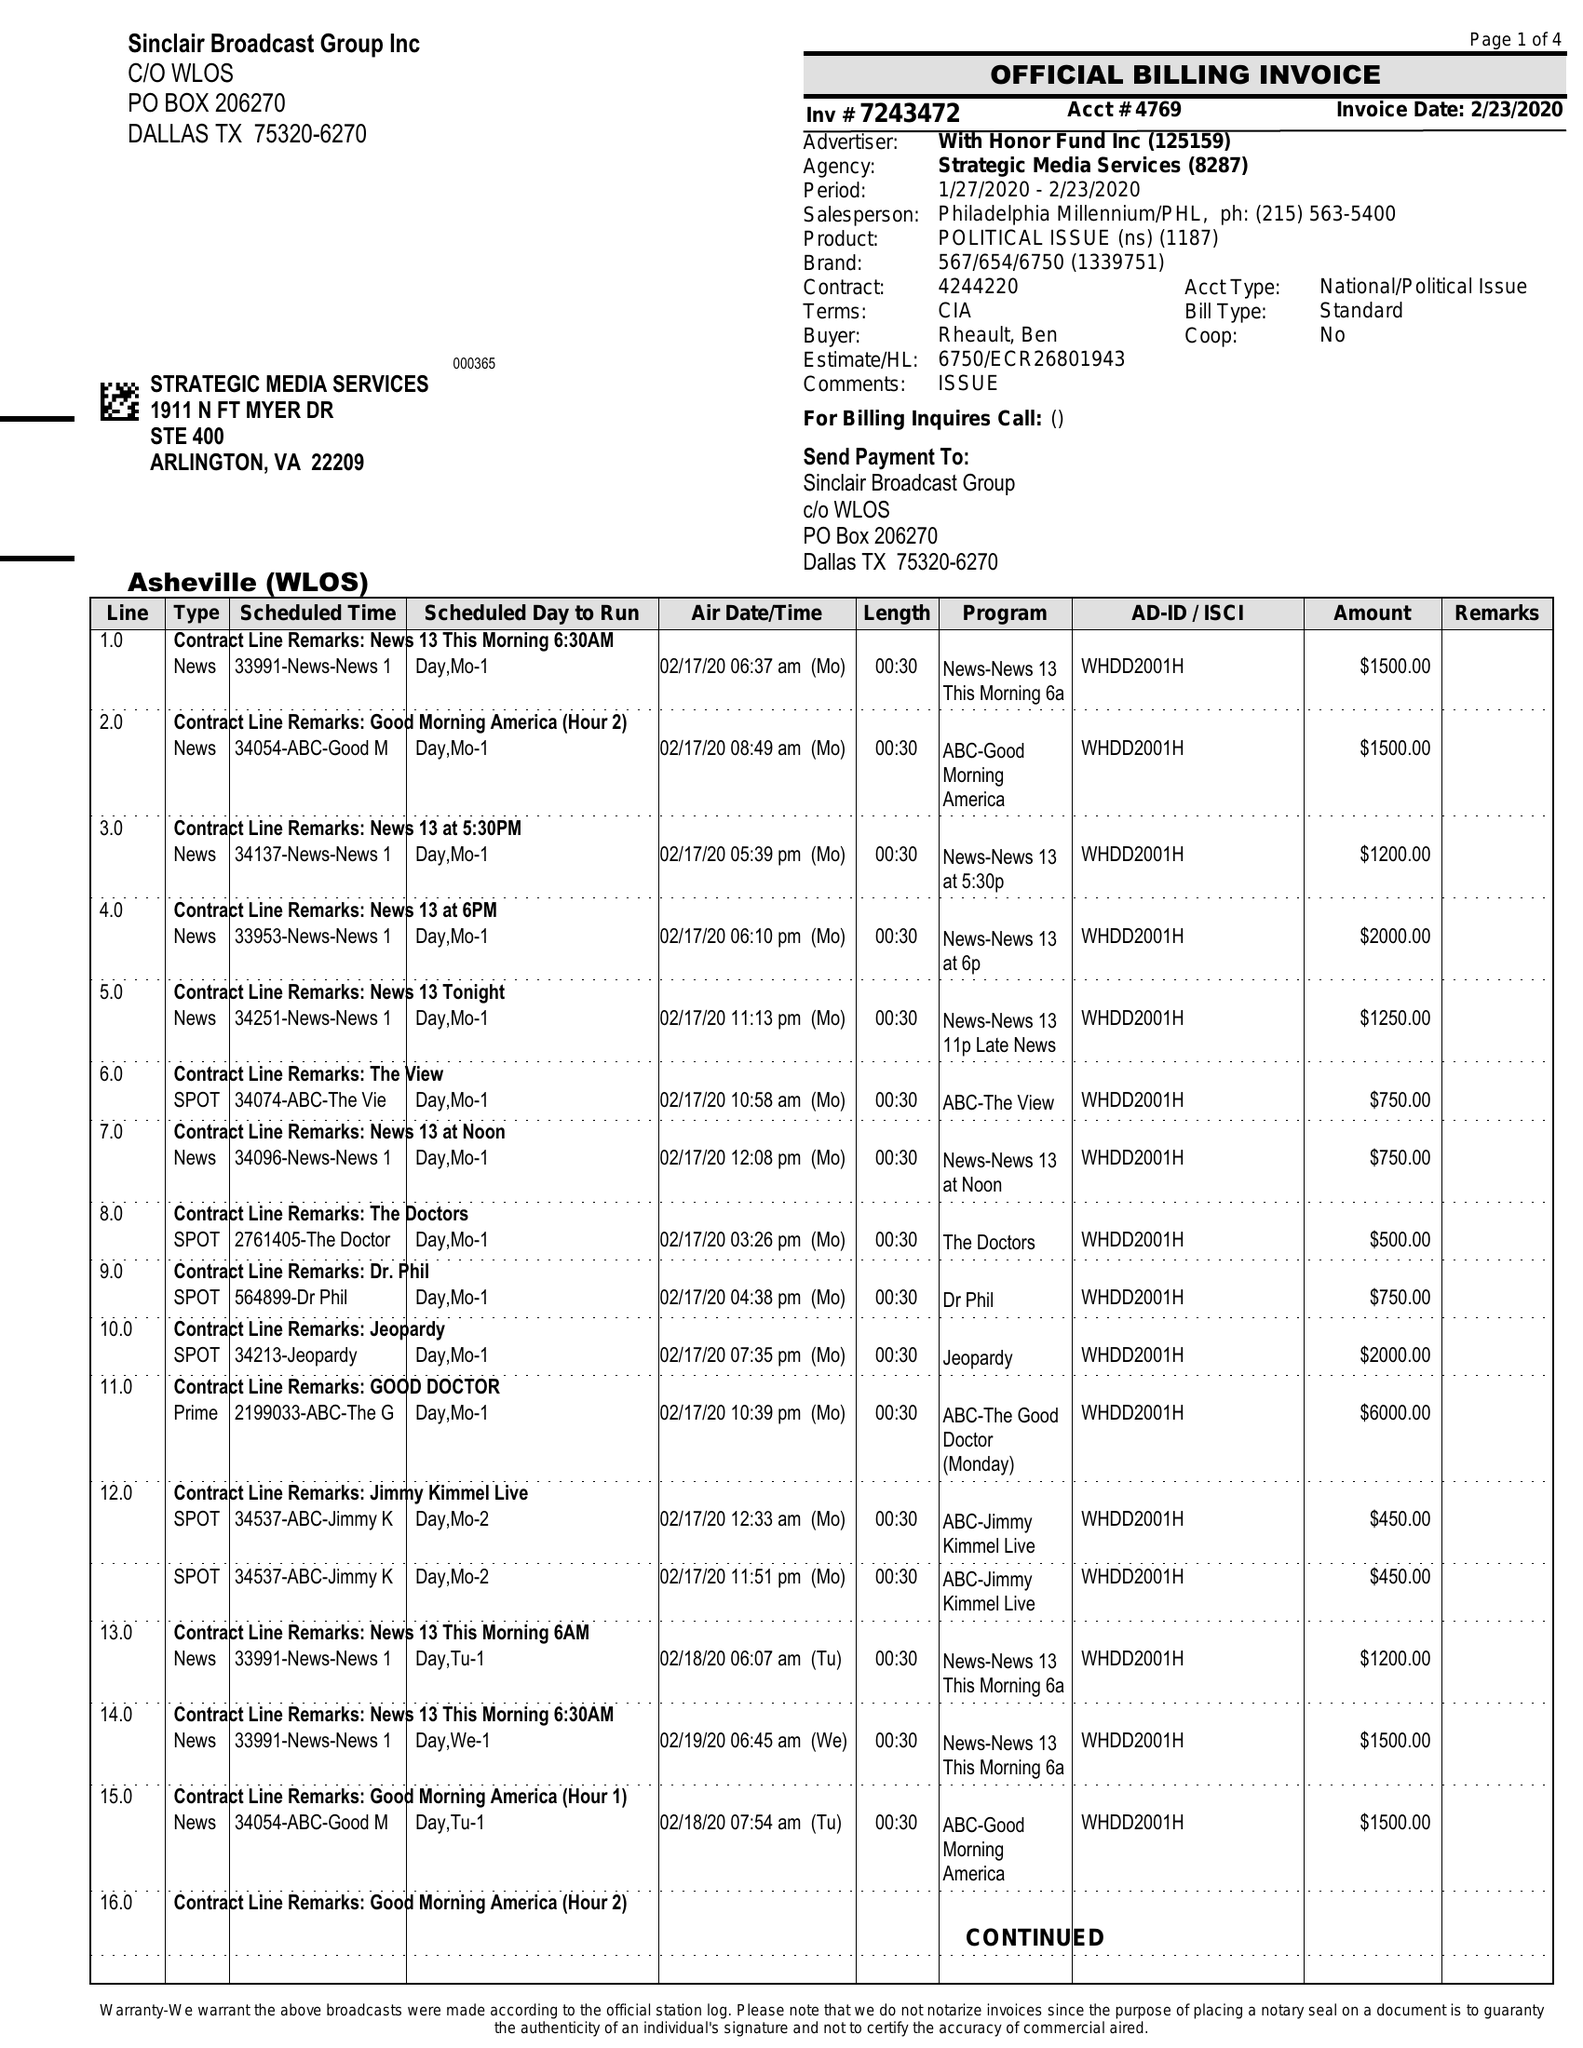What is the value for the flight_to?
Answer the question using a single word or phrase. 02/23/20 